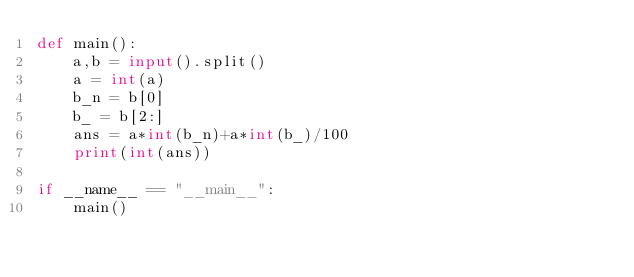<code> <loc_0><loc_0><loc_500><loc_500><_Python_>def main():
    a,b = input().split()
    a = int(a)
    b_n = b[0]
    b_ = b[2:]
    ans = a*int(b_n)+a*int(b_)/100
    print(int(ans))

if __name__ == "__main__":
    main()
</code> 